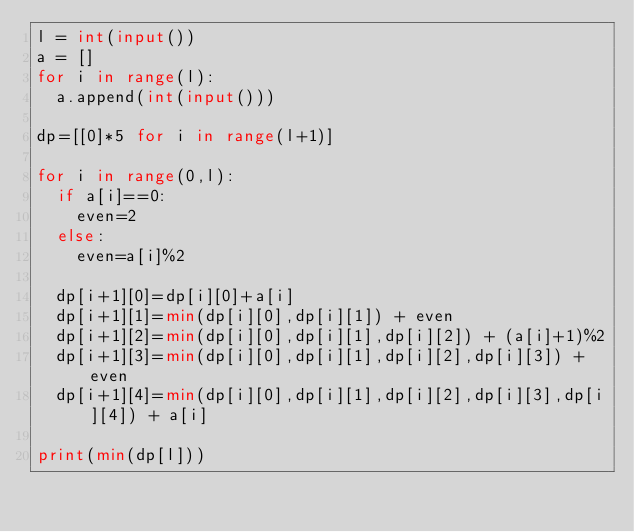Convert code to text. <code><loc_0><loc_0><loc_500><loc_500><_Python_>l = int(input())
a = []
for i in range(l):
  a.append(int(input()))
  
dp=[[0]*5 for i in range(l+1)]

for i in range(0,l):
  if a[i]==0:
    even=2
  else:
    even=a[i]%2
  
  dp[i+1][0]=dp[i][0]+a[i]
  dp[i+1][1]=min(dp[i][0],dp[i][1]) + even
  dp[i+1][2]=min(dp[i][0],dp[i][1],dp[i][2]) + (a[i]+1)%2
  dp[i+1][3]=min(dp[i][0],dp[i][1],dp[i][2],dp[i][3]) + even
  dp[i+1][4]=min(dp[i][0],dp[i][1],dp[i][2],dp[i][3],dp[i][4]) + a[i]
  
print(min(dp[l]))
  </code> 